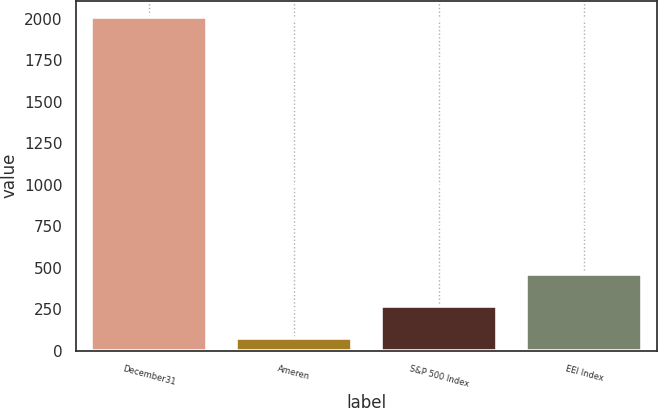Convert chart. <chart><loc_0><loc_0><loc_500><loc_500><bar_chart><fcel>December31<fcel>Ameren<fcel>S&P 500 Index<fcel>EEI Index<nl><fcel>2009<fcel>73.08<fcel>266.67<fcel>460.26<nl></chart> 